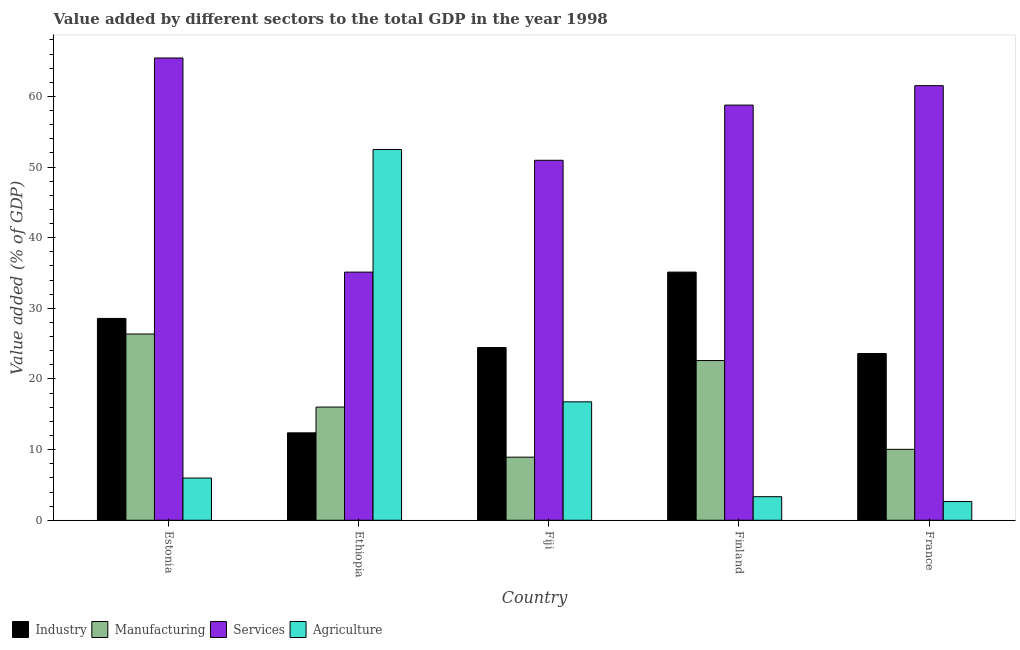Are the number of bars per tick equal to the number of legend labels?
Provide a short and direct response. Yes. What is the label of the 4th group of bars from the left?
Make the answer very short. Finland. In how many cases, is the number of bars for a given country not equal to the number of legend labels?
Your answer should be very brief. 0. What is the value added by services sector in Estonia?
Provide a short and direct response. 65.45. Across all countries, what is the maximum value added by industrial sector?
Ensure brevity in your answer.  35.13. Across all countries, what is the minimum value added by services sector?
Give a very brief answer. 35.13. In which country was the value added by manufacturing sector maximum?
Keep it short and to the point. Estonia. In which country was the value added by industrial sector minimum?
Offer a terse response. Ethiopia. What is the total value added by services sector in the graph?
Your answer should be very brief. 271.85. What is the difference between the value added by industrial sector in Ethiopia and that in Fiji?
Make the answer very short. -12.08. What is the difference between the value added by industrial sector in Fiji and the value added by services sector in Estonia?
Offer a very short reply. -40.99. What is the average value added by industrial sector per country?
Your answer should be compact. 24.83. What is the difference between the value added by manufacturing sector and value added by agricultural sector in Estonia?
Keep it short and to the point. 20.39. What is the ratio of the value added by manufacturing sector in Estonia to that in Ethiopia?
Ensure brevity in your answer.  1.65. Is the value added by industrial sector in Estonia less than that in Ethiopia?
Make the answer very short. No. Is the difference between the value added by manufacturing sector in Finland and France greater than the difference between the value added by industrial sector in Finland and France?
Keep it short and to the point. Yes. What is the difference between the highest and the second highest value added by manufacturing sector?
Keep it short and to the point. 3.76. What is the difference between the highest and the lowest value added by services sector?
Your answer should be compact. 30.31. What does the 4th bar from the left in Fiji represents?
Make the answer very short. Agriculture. What does the 2nd bar from the right in Fiji represents?
Your response must be concise. Services. How many countries are there in the graph?
Make the answer very short. 5. What is the difference between two consecutive major ticks on the Y-axis?
Offer a terse response. 10. Does the graph contain any zero values?
Your answer should be compact. No. How many legend labels are there?
Make the answer very short. 4. What is the title of the graph?
Your answer should be compact. Value added by different sectors to the total GDP in the year 1998. Does "UNTA" appear as one of the legend labels in the graph?
Make the answer very short. No. What is the label or title of the Y-axis?
Give a very brief answer. Value added (% of GDP). What is the Value added (% of GDP) in Industry in Estonia?
Ensure brevity in your answer.  28.58. What is the Value added (% of GDP) of Manufacturing in Estonia?
Provide a short and direct response. 26.37. What is the Value added (% of GDP) of Services in Estonia?
Offer a terse response. 65.45. What is the Value added (% of GDP) in Agriculture in Estonia?
Your response must be concise. 5.98. What is the Value added (% of GDP) of Industry in Ethiopia?
Ensure brevity in your answer.  12.38. What is the Value added (% of GDP) in Manufacturing in Ethiopia?
Offer a very short reply. 16.02. What is the Value added (% of GDP) in Services in Ethiopia?
Make the answer very short. 35.13. What is the Value added (% of GDP) of Agriculture in Ethiopia?
Provide a succinct answer. 52.49. What is the Value added (% of GDP) in Industry in Fiji?
Keep it short and to the point. 24.45. What is the Value added (% of GDP) of Manufacturing in Fiji?
Offer a terse response. 8.93. What is the Value added (% of GDP) of Services in Fiji?
Your answer should be compact. 50.97. What is the Value added (% of GDP) in Agriculture in Fiji?
Your answer should be compact. 16.77. What is the Value added (% of GDP) of Industry in Finland?
Keep it short and to the point. 35.13. What is the Value added (% of GDP) of Manufacturing in Finland?
Give a very brief answer. 22.61. What is the Value added (% of GDP) of Services in Finland?
Provide a short and direct response. 58.78. What is the Value added (% of GDP) in Agriculture in Finland?
Offer a terse response. 3.34. What is the Value added (% of GDP) of Industry in France?
Offer a terse response. 23.61. What is the Value added (% of GDP) of Manufacturing in France?
Offer a very short reply. 10.04. What is the Value added (% of GDP) of Services in France?
Your response must be concise. 61.53. What is the Value added (% of GDP) in Agriculture in France?
Make the answer very short. 2.65. Across all countries, what is the maximum Value added (% of GDP) of Industry?
Provide a succinct answer. 35.13. Across all countries, what is the maximum Value added (% of GDP) of Manufacturing?
Provide a succinct answer. 26.37. Across all countries, what is the maximum Value added (% of GDP) in Services?
Keep it short and to the point. 65.45. Across all countries, what is the maximum Value added (% of GDP) in Agriculture?
Your response must be concise. 52.49. Across all countries, what is the minimum Value added (% of GDP) of Industry?
Provide a short and direct response. 12.38. Across all countries, what is the minimum Value added (% of GDP) in Manufacturing?
Give a very brief answer. 8.93. Across all countries, what is the minimum Value added (% of GDP) of Services?
Your answer should be very brief. 35.13. Across all countries, what is the minimum Value added (% of GDP) of Agriculture?
Your response must be concise. 2.65. What is the total Value added (% of GDP) of Industry in the graph?
Your response must be concise. 124.15. What is the total Value added (% of GDP) in Manufacturing in the graph?
Your response must be concise. 83.98. What is the total Value added (% of GDP) of Services in the graph?
Give a very brief answer. 271.85. What is the total Value added (% of GDP) of Agriculture in the graph?
Provide a short and direct response. 81.22. What is the difference between the Value added (% of GDP) of Industry in Estonia and that in Ethiopia?
Your answer should be very brief. 16.2. What is the difference between the Value added (% of GDP) in Manufacturing in Estonia and that in Ethiopia?
Make the answer very short. 10.34. What is the difference between the Value added (% of GDP) in Services in Estonia and that in Ethiopia?
Your answer should be very brief. 30.31. What is the difference between the Value added (% of GDP) in Agriculture in Estonia and that in Ethiopia?
Ensure brevity in your answer.  -46.51. What is the difference between the Value added (% of GDP) of Industry in Estonia and that in Fiji?
Provide a succinct answer. 4.12. What is the difference between the Value added (% of GDP) in Manufacturing in Estonia and that in Fiji?
Your response must be concise. 17.43. What is the difference between the Value added (% of GDP) of Services in Estonia and that in Fiji?
Give a very brief answer. 14.48. What is the difference between the Value added (% of GDP) of Agriculture in Estonia and that in Fiji?
Offer a terse response. -10.79. What is the difference between the Value added (% of GDP) in Industry in Estonia and that in Finland?
Keep it short and to the point. -6.56. What is the difference between the Value added (% of GDP) in Manufacturing in Estonia and that in Finland?
Ensure brevity in your answer.  3.76. What is the difference between the Value added (% of GDP) in Services in Estonia and that in Finland?
Ensure brevity in your answer.  6.67. What is the difference between the Value added (% of GDP) of Agriculture in Estonia and that in Finland?
Provide a succinct answer. 2.64. What is the difference between the Value added (% of GDP) of Industry in Estonia and that in France?
Offer a very short reply. 4.97. What is the difference between the Value added (% of GDP) of Manufacturing in Estonia and that in France?
Offer a very short reply. 16.33. What is the difference between the Value added (% of GDP) of Services in Estonia and that in France?
Make the answer very short. 3.92. What is the difference between the Value added (% of GDP) in Agriculture in Estonia and that in France?
Your response must be concise. 3.33. What is the difference between the Value added (% of GDP) of Industry in Ethiopia and that in Fiji?
Ensure brevity in your answer.  -12.08. What is the difference between the Value added (% of GDP) of Manufacturing in Ethiopia and that in Fiji?
Keep it short and to the point. 7.09. What is the difference between the Value added (% of GDP) in Services in Ethiopia and that in Fiji?
Provide a succinct answer. -15.83. What is the difference between the Value added (% of GDP) in Agriculture in Ethiopia and that in Fiji?
Offer a terse response. 35.72. What is the difference between the Value added (% of GDP) of Industry in Ethiopia and that in Finland?
Offer a terse response. -22.76. What is the difference between the Value added (% of GDP) of Manufacturing in Ethiopia and that in Finland?
Ensure brevity in your answer.  -6.59. What is the difference between the Value added (% of GDP) of Services in Ethiopia and that in Finland?
Your answer should be compact. -23.65. What is the difference between the Value added (% of GDP) of Agriculture in Ethiopia and that in Finland?
Offer a terse response. 49.15. What is the difference between the Value added (% of GDP) of Industry in Ethiopia and that in France?
Provide a short and direct response. -11.23. What is the difference between the Value added (% of GDP) of Manufacturing in Ethiopia and that in France?
Give a very brief answer. 5.98. What is the difference between the Value added (% of GDP) of Services in Ethiopia and that in France?
Keep it short and to the point. -26.4. What is the difference between the Value added (% of GDP) of Agriculture in Ethiopia and that in France?
Your response must be concise. 49.84. What is the difference between the Value added (% of GDP) of Industry in Fiji and that in Finland?
Your response must be concise. -10.68. What is the difference between the Value added (% of GDP) of Manufacturing in Fiji and that in Finland?
Offer a very short reply. -13.68. What is the difference between the Value added (% of GDP) of Services in Fiji and that in Finland?
Make the answer very short. -7.81. What is the difference between the Value added (% of GDP) of Agriculture in Fiji and that in Finland?
Ensure brevity in your answer.  13.43. What is the difference between the Value added (% of GDP) of Industry in Fiji and that in France?
Your answer should be very brief. 0.85. What is the difference between the Value added (% of GDP) of Manufacturing in Fiji and that in France?
Your response must be concise. -1.11. What is the difference between the Value added (% of GDP) of Services in Fiji and that in France?
Your response must be concise. -10.56. What is the difference between the Value added (% of GDP) of Agriculture in Fiji and that in France?
Provide a short and direct response. 14.12. What is the difference between the Value added (% of GDP) of Industry in Finland and that in France?
Make the answer very short. 11.53. What is the difference between the Value added (% of GDP) of Manufacturing in Finland and that in France?
Provide a short and direct response. 12.57. What is the difference between the Value added (% of GDP) of Services in Finland and that in France?
Keep it short and to the point. -2.75. What is the difference between the Value added (% of GDP) of Agriculture in Finland and that in France?
Keep it short and to the point. 0.69. What is the difference between the Value added (% of GDP) in Industry in Estonia and the Value added (% of GDP) in Manufacturing in Ethiopia?
Give a very brief answer. 12.55. What is the difference between the Value added (% of GDP) of Industry in Estonia and the Value added (% of GDP) of Services in Ethiopia?
Ensure brevity in your answer.  -6.56. What is the difference between the Value added (% of GDP) of Industry in Estonia and the Value added (% of GDP) of Agriculture in Ethiopia?
Give a very brief answer. -23.91. What is the difference between the Value added (% of GDP) in Manufacturing in Estonia and the Value added (% of GDP) in Services in Ethiopia?
Ensure brevity in your answer.  -8.77. What is the difference between the Value added (% of GDP) in Manufacturing in Estonia and the Value added (% of GDP) in Agriculture in Ethiopia?
Give a very brief answer. -26.12. What is the difference between the Value added (% of GDP) of Services in Estonia and the Value added (% of GDP) of Agriculture in Ethiopia?
Your answer should be compact. 12.96. What is the difference between the Value added (% of GDP) of Industry in Estonia and the Value added (% of GDP) of Manufacturing in Fiji?
Offer a very short reply. 19.64. What is the difference between the Value added (% of GDP) in Industry in Estonia and the Value added (% of GDP) in Services in Fiji?
Your answer should be compact. -22.39. What is the difference between the Value added (% of GDP) of Industry in Estonia and the Value added (% of GDP) of Agriculture in Fiji?
Keep it short and to the point. 11.81. What is the difference between the Value added (% of GDP) in Manufacturing in Estonia and the Value added (% of GDP) in Services in Fiji?
Give a very brief answer. -24.6. What is the difference between the Value added (% of GDP) of Manufacturing in Estonia and the Value added (% of GDP) of Agriculture in Fiji?
Offer a terse response. 9.6. What is the difference between the Value added (% of GDP) of Services in Estonia and the Value added (% of GDP) of Agriculture in Fiji?
Ensure brevity in your answer.  48.68. What is the difference between the Value added (% of GDP) of Industry in Estonia and the Value added (% of GDP) of Manufacturing in Finland?
Offer a very short reply. 5.96. What is the difference between the Value added (% of GDP) of Industry in Estonia and the Value added (% of GDP) of Services in Finland?
Ensure brevity in your answer.  -30.2. What is the difference between the Value added (% of GDP) in Industry in Estonia and the Value added (% of GDP) in Agriculture in Finland?
Provide a short and direct response. 25.24. What is the difference between the Value added (% of GDP) in Manufacturing in Estonia and the Value added (% of GDP) in Services in Finland?
Offer a very short reply. -32.41. What is the difference between the Value added (% of GDP) of Manufacturing in Estonia and the Value added (% of GDP) of Agriculture in Finland?
Ensure brevity in your answer.  23.03. What is the difference between the Value added (% of GDP) in Services in Estonia and the Value added (% of GDP) in Agriculture in Finland?
Ensure brevity in your answer.  62.11. What is the difference between the Value added (% of GDP) in Industry in Estonia and the Value added (% of GDP) in Manufacturing in France?
Ensure brevity in your answer.  18.53. What is the difference between the Value added (% of GDP) in Industry in Estonia and the Value added (% of GDP) in Services in France?
Keep it short and to the point. -32.95. What is the difference between the Value added (% of GDP) of Industry in Estonia and the Value added (% of GDP) of Agriculture in France?
Your response must be concise. 25.93. What is the difference between the Value added (% of GDP) of Manufacturing in Estonia and the Value added (% of GDP) of Services in France?
Provide a succinct answer. -35.16. What is the difference between the Value added (% of GDP) in Manufacturing in Estonia and the Value added (% of GDP) in Agriculture in France?
Provide a short and direct response. 23.72. What is the difference between the Value added (% of GDP) in Services in Estonia and the Value added (% of GDP) in Agriculture in France?
Provide a succinct answer. 62.8. What is the difference between the Value added (% of GDP) of Industry in Ethiopia and the Value added (% of GDP) of Manufacturing in Fiji?
Provide a short and direct response. 3.45. What is the difference between the Value added (% of GDP) of Industry in Ethiopia and the Value added (% of GDP) of Services in Fiji?
Offer a terse response. -38.59. What is the difference between the Value added (% of GDP) in Industry in Ethiopia and the Value added (% of GDP) in Agriculture in Fiji?
Make the answer very short. -4.39. What is the difference between the Value added (% of GDP) in Manufacturing in Ethiopia and the Value added (% of GDP) in Services in Fiji?
Provide a succinct answer. -34.94. What is the difference between the Value added (% of GDP) of Manufacturing in Ethiopia and the Value added (% of GDP) of Agriculture in Fiji?
Offer a terse response. -0.74. What is the difference between the Value added (% of GDP) in Services in Ethiopia and the Value added (% of GDP) in Agriculture in Fiji?
Ensure brevity in your answer.  18.37. What is the difference between the Value added (% of GDP) in Industry in Ethiopia and the Value added (% of GDP) in Manufacturing in Finland?
Your answer should be very brief. -10.23. What is the difference between the Value added (% of GDP) in Industry in Ethiopia and the Value added (% of GDP) in Services in Finland?
Provide a short and direct response. -46.4. What is the difference between the Value added (% of GDP) in Industry in Ethiopia and the Value added (% of GDP) in Agriculture in Finland?
Provide a short and direct response. 9.04. What is the difference between the Value added (% of GDP) in Manufacturing in Ethiopia and the Value added (% of GDP) in Services in Finland?
Your answer should be very brief. -42.76. What is the difference between the Value added (% of GDP) in Manufacturing in Ethiopia and the Value added (% of GDP) in Agriculture in Finland?
Provide a succinct answer. 12.69. What is the difference between the Value added (% of GDP) in Services in Ethiopia and the Value added (% of GDP) in Agriculture in Finland?
Provide a succinct answer. 31.8. What is the difference between the Value added (% of GDP) in Industry in Ethiopia and the Value added (% of GDP) in Manufacturing in France?
Make the answer very short. 2.34. What is the difference between the Value added (% of GDP) in Industry in Ethiopia and the Value added (% of GDP) in Services in France?
Keep it short and to the point. -49.15. What is the difference between the Value added (% of GDP) in Industry in Ethiopia and the Value added (% of GDP) in Agriculture in France?
Make the answer very short. 9.73. What is the difference between the Value added (% of GDP) in Manufacturing in Ethiopia and the Value added (% of GDP) in Services in France?
Give a very brief answer. -45.5. What is the difference between the Value added (% of GDP) of Manufacturing in Ethiopia and the Value added (% of GDP) of Agriculture in France?
Keep it short and to the point. 13.37. What is the difference between the Value added (% of GDP) in Services in Ethiopia and the Value added (% of GDP) in Agriculture in France?
Your answer should be very brief. 32.48. What is the difference between the Value added (% of GDP) of Industry in Fiji and the Value added (% of GDP) of Manufacturing in Finland?
Provide a short and direct response. 1.84. What is the difference between the Value added (% of GDP) of Industry in Fiji and the Value added (% of GDP) of Services in Finland?
Your response must be concise. -34.33. What is the difference between the Value added (% of GDP) in Industry in Fiji and the Value added (% of GDP) in Agriculture in Finland?
Offer a very short reply. 21.12. What is the difference between the Value added (% of GDP) in Manufacturing in Fiji and the Value added (% of GDP) in Services in Finland?
Offer a terse response. -49.85. What is the difference between the Value added (% of GDP) in Manufacturing in Fiji and the Value added (% of GDP) in Agriculture in Finland?
Keep it short and to the point. 5.6. What is the difference between the Value added (% of GDP) in Services in Fiji and the Value added (% of GDP) in Agriculture in Finland?
Ensure brevity in your answer.  47.63. What is the difference between the Value added (% of GDP) in Industry in Fiji and the Value added (% of GDP) in Manufacturing in France?
Offer a terse response. 14.41. What is the difference between the Value added (% of GDP) in Industry in Fiji and the Value added (% of GDP) in Services in France?
Provide a succinct answer. -37.08. What is the difference between the Value added (% of GDP) in Industry in Fiji and the Value added (% of GDP) in Agriculture in France?
Keep it short and to the point. 21.8. What is the difference between the Value added (% of GDP) of Manufacturing in Fiji and the Value added (% of GDP) of Services in France?
Your answer should be very brief. -52.6. What is the difference between the Value added (% of GDP) in Manufacturing in Fiji and the Value added (% of GDP) in Agriculture in France?
Your response must be concise. 6.28. What is the difference between the Value added (% of GDP) of Services in Fiji and the Value added (% of GDP) of Agriculture in France?
Your answer should be compact. 48.32. What is the difference between the Value added (% of GDP) in Industry in Finland and the Value added (% of GDP) in Manufacturing in France?
Your response must be concise. 25.09. What is the difference between the Value added (% of GDP) of Industry in Finland and the Value added (% of GDP) of Services in France?
Make the answer very short. -26.39. What is the difference between the Value added (% of GDP) in Industry in Finland and the Value added (% of GDP) in Agriculture in France?
Keep it short and to the point. 32.48. What is the difference between the Value added (% of GDP) in Manufacturing in Finland and the Value added (% of GDP) in Services in France?
Offer a terse response. -38.92. What is the difference between the Value added (% of GDP) in Manufacturing in Finland and the Value added (% of GDP) in Agriculture in France?
Your answer should be compact. 19.96. What is the difference between the Value added (% of GDP) in Services in Finland and the Value added (% of GDP) in Agriculture in France?
Offer a terse response. 56.13. What is the average Value added (% of GDP) in Industry per country?
Offer a very short reply. 24.83. What is the average Value added (% of GDP) of Manufacturing per country?
Ensure brevity in your answer.  16.8. What is the average Value added (% of GDP) in Services per country?
Offer a very short reply. 54.37. What is the average Value added (% of GDP) in Agriculture per country?
Make the answer very short. 16.24. What is the difference between the Value added (% of GDP) in Industry and Value added (% of GDP) in Manufacturing in Estonia?
Provide a succinct answer. 2.21. What is the difference between the Value added (% of GDP) in Industry and Value added (% of GDP) in Services in Estonia?
Offer a terse response. -36.87. What is the difference between the Value added (% of GDP) of Industry and Value added (% of GDP) of Agriculture in Estonia?
Offer a terse response. 22.6. What is the difference between the Value added (% of GDP) in Manufacturing and Value added (% of GDP) in Services in Estonia?
Your response must be concise. -39.08. What is the difference between the Value added (% of GDP) of Manufacturing and Value added (% of GDP) of Agriculture in Estonia?
Keep it short and to the point. 20.39. What is the difference between the Value added (% of GDP) of Services and Value added (% of GDP) of Agriculture in Estonia?
Offer a very short reply. 59.47. What is the difference between the Value added (% of GDP) of Industry and Value added (% of GDP) of Manufacturing in Ethiopia?
Your answer should be very brief. -3.65. What is the difference between the Value added (% of GDP) in Industry and Value added (% of GDP) in Services in Ethiopia?
Provide a short and direct response. -22.76. What is the difference between the Value added (% of GDP) of Industry and Value added (% of GDP) of Agriculture in Ethiopia?
Offer a terse response. -40.11. What is the difference between the Value added (% of GDP) of Manufacturing and Value added (% of GDP) of Services in Ethiopia?
Your answer should be very brief. -19.11. What is the difference between the Value added (% of GDP) of Manufacturing and Value added (% of GDP) of Agriculture in Ethiopia?
Offer a terse response. -36.46. What is the difference between the Value added (% of GDP) in Services and Value added (% of GDP) in Agriculture in Ethiopia?
Offer a very short reply. -17.35. What is the difference between the Value added (% of GDP) of Industry and Value added (% of GDP) of Manufacturing in Fiji?
Keep it short and to the point. 15.52. What is the difference between the Value added (% of GDP) of Industry and Value added (% of GDP) of Services in Fiji?
Make the answer very short. -26.51. What is the difference between the Value added (% of GDP) in Industry and Value added (% of GDP) in Agriculture in Fiji?
Give a very brief answer. 7.69. What is the difference between the Value added (% of GDP) of Manufacturing and Value added (% of GDP) of Services in Fiji?
Provide a short and direct response. -42.03. What is the difference between the Value added (% of GDP) in Manufacturing and Value added (% of GDP) in Agriculture in Fiji?
Offer a terse response. -7.83. What is the difference between the Value added (% of GDP) in Services and Value added (% of GDP) in Agriculture in Fiji?
Your answer should be compact. 34.2. What is the difference between the Value added (% of GDP) in Industry and Value added (% of GDP) in Manufacturing in Finland?
Your answer should be very brief. 12.52. What is the difference between the Value added (% of GDP) of Industry and Value added (% of GDP) of Services in Finland?
Your answer should be compact. -23.65. What is the difference between the Value added (% of GDP) in Industry and Value added (% of GDP) in Agriculture in Finland?
Provide a short and direct response. 31.8. What is the difference between the Value added (% of GDP) of Manufacturing and Value added (% of GDP) of Services in Finland?
Your answer should be compact. -36.17. What is the difference between the Value added (% of GDP) of Manufacturing and Value added (% of GDP) of Agriculture in Finland?
Offer a terse response. 19.27. What is the difference between the Value added (% of GDP) of Services and Value added (% of GDP) of Agriculture in Finland?
Keep it short and to the point. 55.44. What is the difference between the Value added (% of GDP) in Industry and Value added (% of GDP) in Manufacturing in France?
Your answer should be compact. 13.57. What is the difference between the Value added (% of GDP) in Industry and Value added (% of GDP) in Services in France?
Make the answer very short. -37.92. What is the difference between the Value added (% of GDP) of Industry and Value added (% of GDP) of Agriculture in France?
Give a very brief answer. 20.96. What is the difference between the Value added (% of GDP) of Manufacturing and Value added (% of GDP) of Services in France?
Provide a succinct answer. -51.49. What is the difference between the Value added (% of GDP) in Manufacturing and Value added (% of GDP) in Agriculture in France?
Offer a terse response. 7.39. What is the difference between the Value added (% of GDP) in Services and Value added (% of GDP) in Agriculture in France?
Keep it short and to the point. 58.88. What is the ratio of the Value added (% of GDP) in Industry in Estonia to that in Ethiopia?
Your answer should be compact. 2.31. What is the ratio of the Value added (% of GDP) in Manufacturing in Estonia to that in Ethiopia?
Make the answer very short. 1.65. What is the ratio of the Value added (% of GDP) in Services in Estonia to that in Ethiopia?
Ensure brevity in your answer.  1.86. What is the ratio of the Value added (% of GDP) in Agriculture in Estonia to that in Ethiopia?
Your answer should be compact. 0.11. What is the ratio of the Value added (% of GDP) in Industry in Estonia to that in Fiji?
Keep it short and to the point. 1.17. What is the ratio of the Value added (% of GDP) of Manufacturing in Estonia to that in Fiji?
Provide a short and direct response. 2.95. What is the ratio of the Value added (% of GDP) of Services in Estonia to that in Fiji?
Give a very brief answer. 1.28. What is the ratio of the Value added (% of GDP) in Agriculture in Estonia to that in Fiji?
Ensure brevity in your answer.  0.36. What is the ratio of the Value added (% of GDP) in Industry in Estonia to that in Finland?
Offer a terse response. 0.81. What is the ratio of the Value added (% of GDP) of Manufacturing in Estonia to that in Finland?
Offer a terse response. 1.17. What is the ratio of the Value added (% of GDP) in Services in Estonia to that in Finland?
Offer a very short reply. 1.11. What is the ratio of the Value added (% of GDP) in Agriculture in Estonia to that in Finland?
Offer a very short reply. 1.79. What is the ratio of the Value added (% of GDP) of Industry in Estonia to that in France?
Make the answer very short. 1.21. What is the ratio of the Value added (% of GDP) in Manufacturing in Estonia to that in France?
Make the answer very short. 2.63. What is the ratio of the Value added (% of GDP) of Services in Estonia to that in France?
Ensure brevity in your answer.  1.06. What is the ratio of the Value added (% of GDP) of Agriculture in Estonia to that in France?
Ensure brevity in your answer.  2.26. What is the ratio of the Value added (% of GDP) in Industry in Ethiopia to that in Fiji?
Your answer should be very brief. 0.51. What is the ratio of the Value added (% of GDP) in Manufacturing in Ethiopia to that in Fiji?
Make the answer very short. 1.79. What is the ratio of the Value added (% of GDP) of Services in Ethiopia to that in Fiji?
Ensure brevity in your answer.  0.69. What is the ratio of the Value added (% of GDP) in Agriculture in Ethiopia to that in Fiji?
Ensure brevity in your answer.  3.13. What is the ratio of the Value added (% of GDP) of Industry in Ethiopia to that in Finland?
Ensure brevity in your answer.  0.35. What is the ratio of the Value added (% of GDP) of Manufacturing in Ethiopia to that in Finland?
Offer a terse response. 0.71. What is the ratio of the Value added (% of GDP) in Services in Ethiopia to that in Finland?
Give a very brief answer. 0.6. What is the ratio of the Value added (% of GDP) of Agriculture in Ethiopia to that in Finland?
Your answer should be compact. 15.73. What is the ratio of the Value added (% of GDP) of Industry in Ethiopia to that in France?
Your answer should be very brief. 0.52. What is the ratio of the Value added (% of GDP) in Manufacturing in Ethiopia to that in France?
Provide a short and direct response. 1.6. What is the ratio of the Value added (% of GDP) in Services in Ethiopia to that in France?
Provide a short and direct response. 0.57. What is the ratio of the Value added (% of GDP) of Agriculture in Ethiopia to that in France?
Offer a terse response. 19.81. What is the ratio of the Value added (% of GDP) of Industry in Fiji to that in Finland?
Offer a very short reply. 0.7. What is the ratio of the Value added (% of GDP) of Manufacturing in Fiji to that in Finland?
Offer a very short reply. 0.4. What is the ratio of the Value added (% of GDP) of Services in Fiji to that in Finland?
Give a very brief answer. 0.87. What is the ratio of the Value added (% of GDP) of Agriculture in Fiji to that in Finland?
Keep it short and to the point. 5.02. What is the ratio of the Value added (% of GDP) in Industry in Fiji to that in France?
Keep it short and to the point. 1.04. What is the ratio of the Value added (% of GDP) in Manufacturing in Fiji to that in France?
Give a very brief answer. 0.89. What is the ratio of the Value added (% of GDP) of Services in Fiji to that in France?
Give a very brief answer. 0.83. What is the ratio of the Value added (% of GDP) in Agriculture in Fiji to that in France?
Make the answer very short. 6.33. What is the ratio of the Value added (% of GDP) in Industry in Finland to that in France?
Your response must be concise. 1.49. What is the ratio of the Value added (% of GDP) of Manufacturing in Finland to that in France?
Your answer should be very brief. 2.25. What is the ratio of the Value added (% of GDP) in Services in Finland to that in France?
Give a very brief answer. 0.96. What is the ratio of the Value added (% of GDP) of Agriculture in Finland to that in France?
Give a very brief answer. 1.26. What is the difference between the highest and the second highest Value added (% of GDP) of Industry?
Provide a succinct answer. 6.56. What is the difference between the highest and the second highest Value added (% of GDP) of Manufacturing?
Provide a short and direct response. 3.76. What is the difference between the highest and the second highest Value added (% of GDP) of Services?
Your answer should be compact. 3.92. What is the difference between the highest and the second highest Value added (% of GDP) of Agriculture?
Your response must be concise. 35.72. What is the difference between the highest and the lowest Value added (% of GDP) in Industry?
Offer a very short reply. 22.76. What is the difference between the highest and the lowest Value added (% of GDP) in Manufacturing?
Keep it short and to the point. 17.43. What is the difference between the highest and the lowest Value added (% of GDP) of Services?
Your response must be concise. 30.31. What is the difference between the highest and the lowest Value added (% of GDP) in Agriculture?
Your response must be concise. 49.84. 